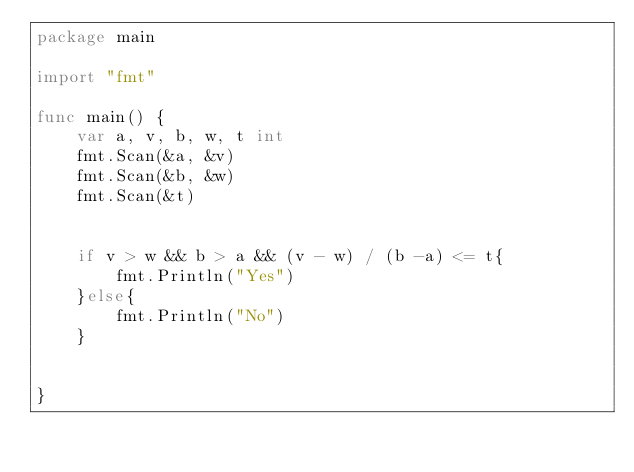Convert code to text. <code><loc_0><loc_0><loc_500><loc_500><_Go_>package main

import "fmt"

func main() {
	var a, v, b, w, t int
	fmt.Scan(&a, &v)
	fmt.Scan(&b, &w)
	fmt.Scan(&t)


	if v > w && b > a && (v - w) / (b -a) <= t{
		fmt.Println("Yes")
	}else{
		fmt.Println("No")
	}


}</code> 